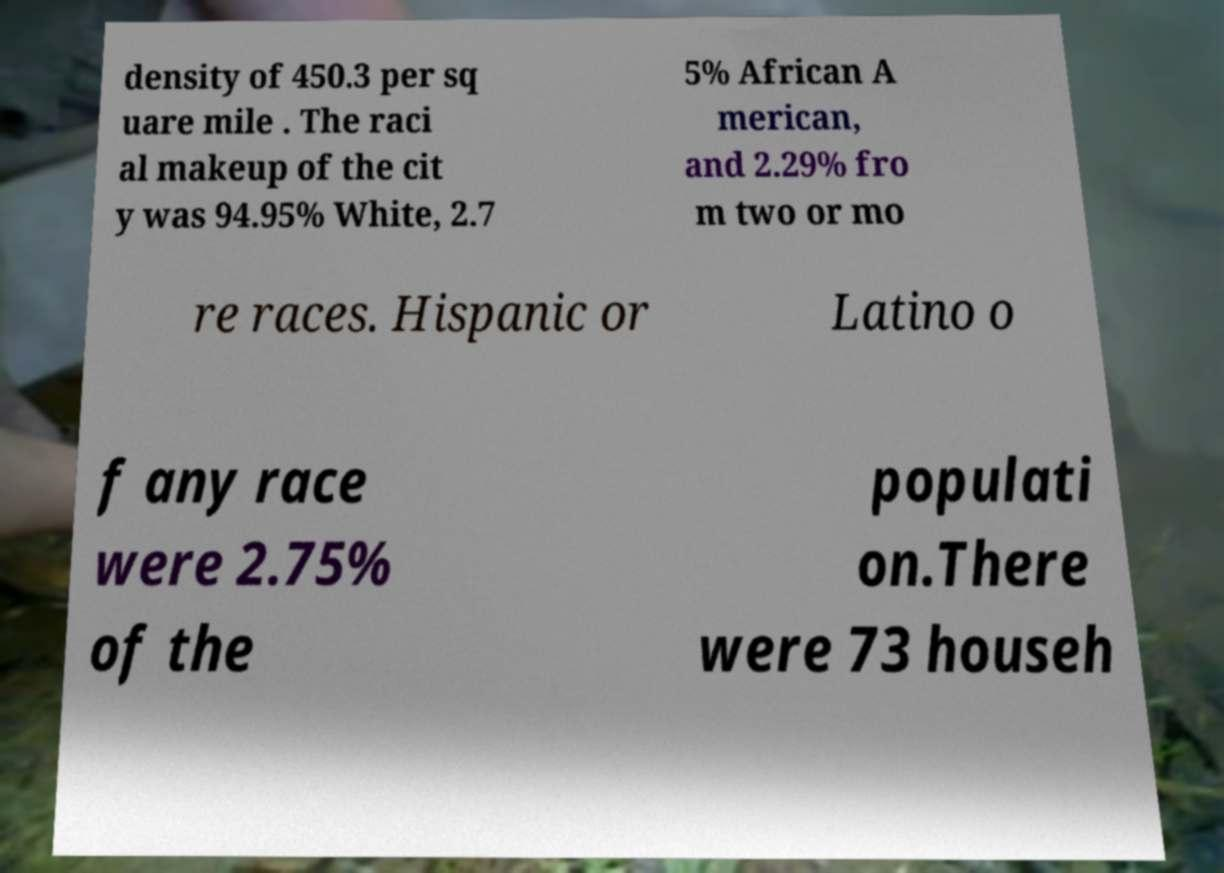Can you read and provide the text displayed in the image?This photo seems to have some interesting text. Can you extract and type it out for me? density of 450.3 per sq uare mile . The raci al makeup of the cit y was 94.95% White, 2.7 5% African A merican, and 2.29% fro m two or mo re races. Hispanic or Latino o f any race were 2.75% of the populati on.There were 73 househ 